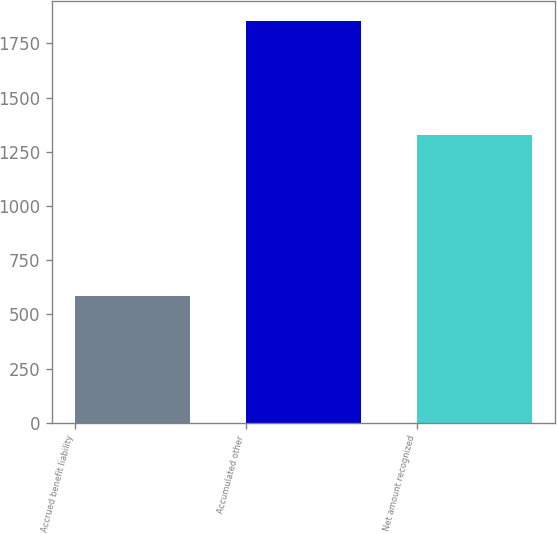Convert chart to OTSL. <chart><loc_0><loc_0><loc_500><loc_500><bar_chart><fcel>Accrued benefit liability<fcel>Accumulated other<fcel>Net amount recognized<nl><fcel>583<fcel>1853<fcel>1329<nl></chart> 